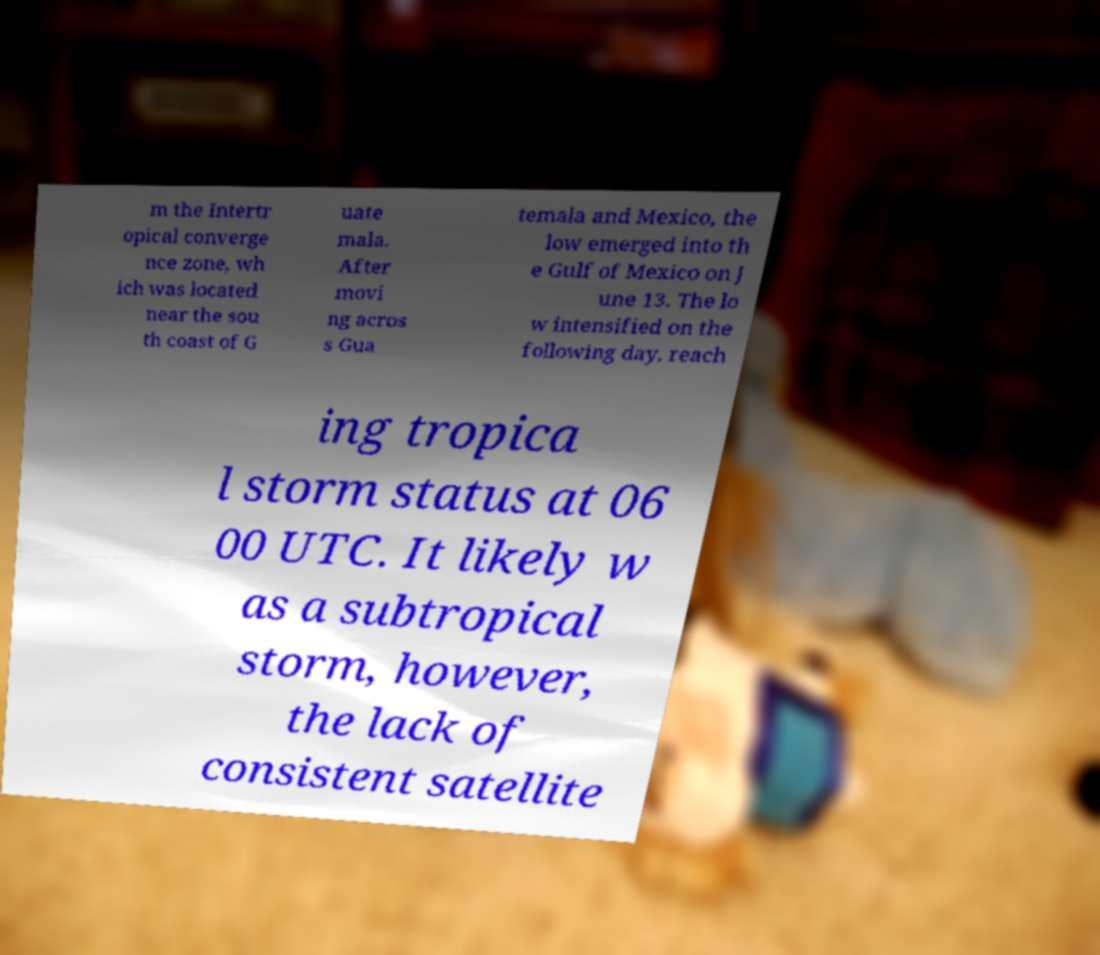I need the written content from this picture converted into text. Can you do that? m the Intertr opical converge nce zone, wh ich was located near the sou th coast of G uate mala. After movi ng acros s Gua temala and Mexico, the low emerged into th e Gulf of Mexico on J une 13. The lo w intensified on the following day, reach ing tropica l storm status at 06 00 UTC. It likely w as a subtropical storm, however, the lack of consistent satellite 